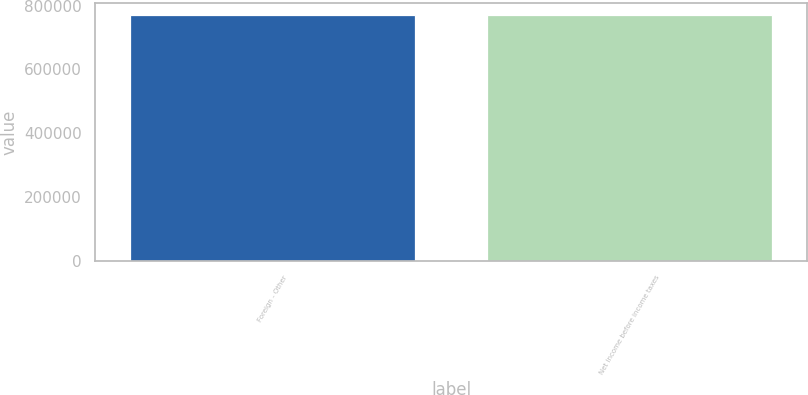Convert chart to OTSL. <chart><loc_0><loc_0><loc_500><loc_500><bar_chart><fcel>Foreign - Other<fcel>Net income before income taxes<nl><fcel>770614<fcel>770614<nl></chart> 